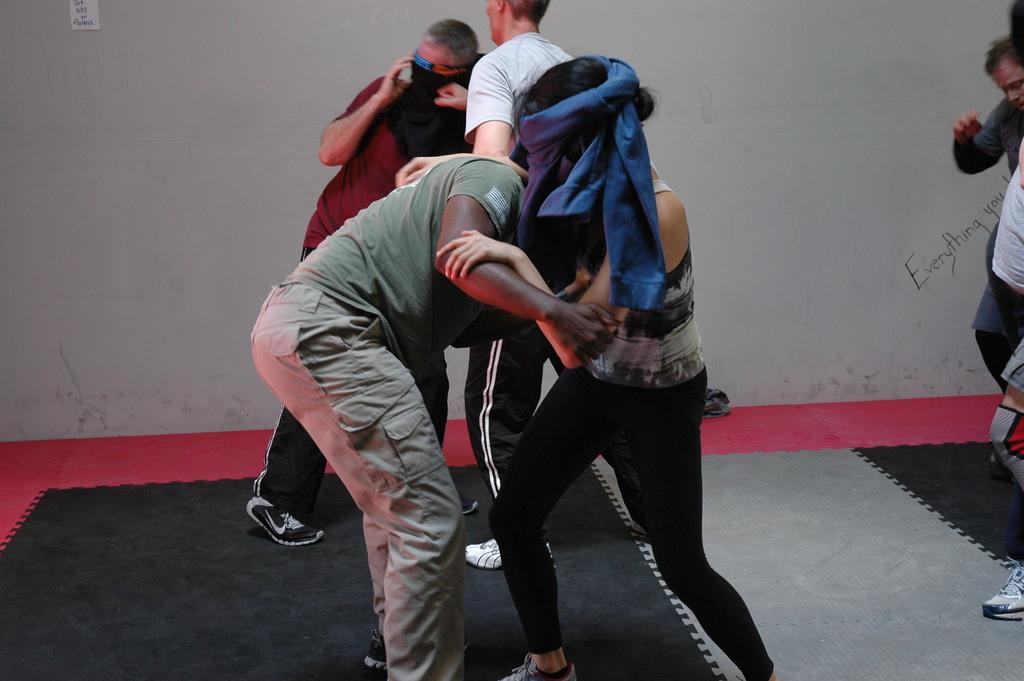Who or what can be seen in the image? There are people in the image. What is an unusual feature of the room in the image? There is a carpet on the wall. What can be seen in the background of the image? There is a wall visible in the background. What type of guitar can be heard playing in the image? There is no guitar or sound present in the image; it only shows people and a carpet on the wall. 